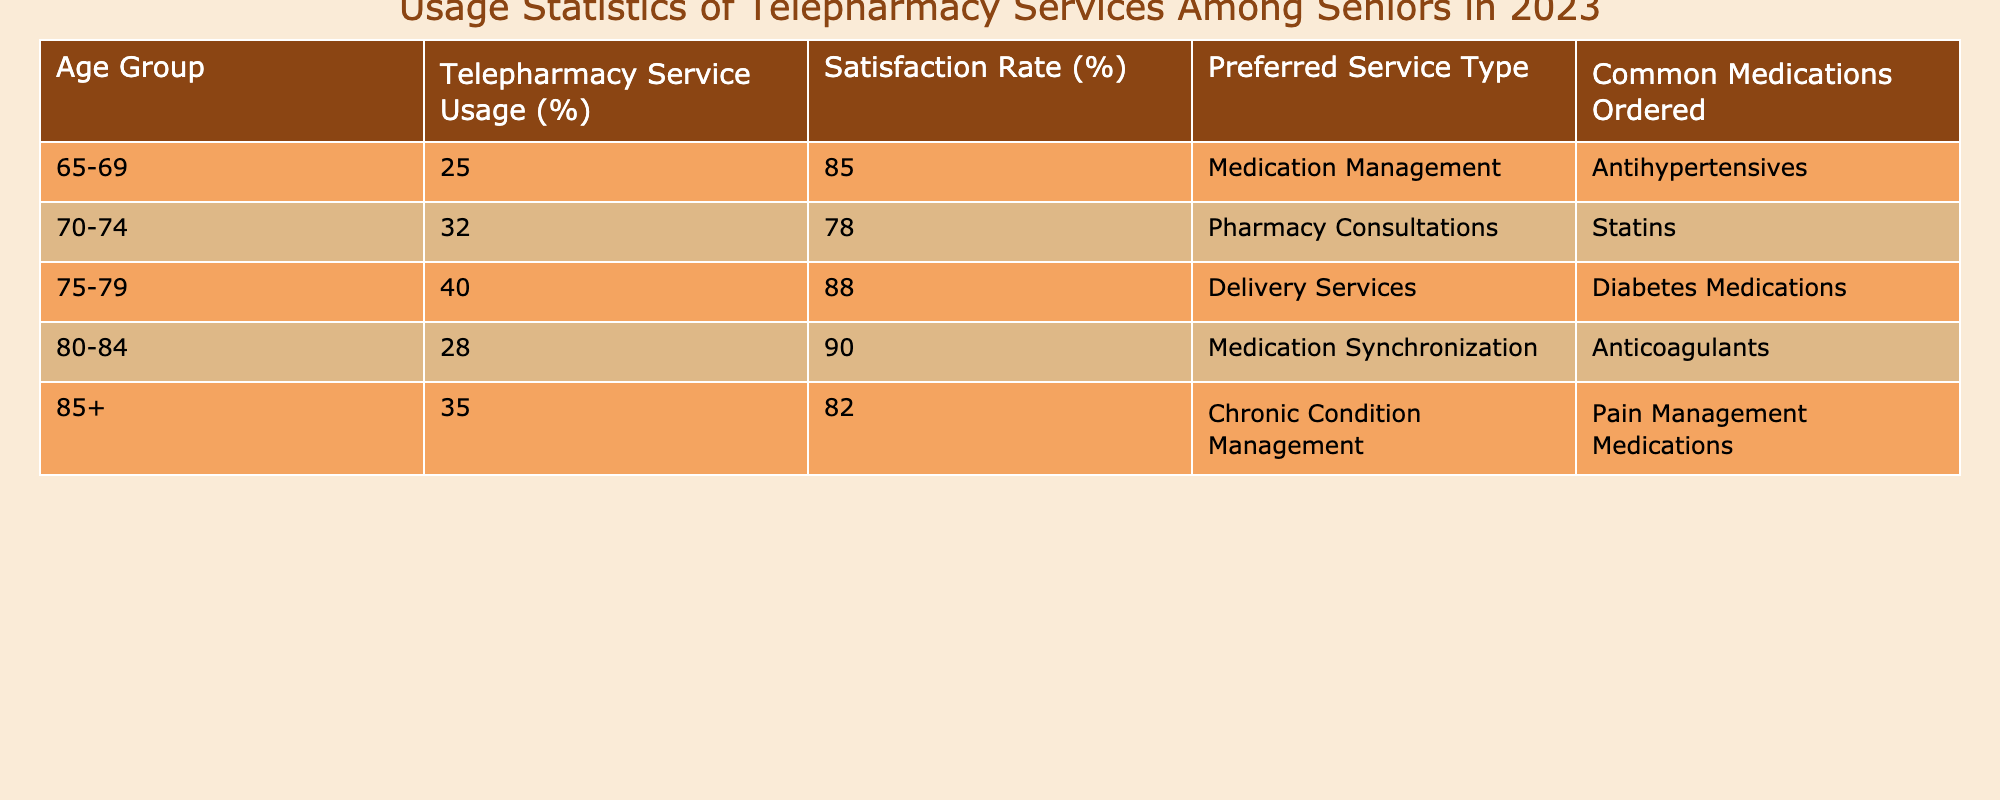What percentage of seniors aged 75-79 use telepharmacy services? According to the table, the percentage of seniors aged 75-79 who use telepharmacy services is explicitly stated as 40%.
Answer: 40% What is the satisfaction rate for seniors aged 80-84? The table shows that the satisfaction rate for seniors aged 80-84 is 90%.
Answer: 90% Which age group has the highest percentage of telepharmacy service usage? By comparing the usage percentages across the age groups, it's clear that seniors aged 75-79 have the highest percentage at 40%.
Answer: 75-79 What is the preferred service type for seniors aged 70-74? The table indicates that the preferred service type for this age group is Pharmacy Consultations.
Answer: Pharmacy Consultations What's the average satisfaction rate across all age groups? To find the average, add the satisfaction rates (85 + 78 + 88 + 90 + 82) = 421, and then divide by 5 (the number of groups), which equals 84.2%.
Answer: 84.2% Do more seniors aged 65-69 prefer medication management or delivery services? The table shows that the preferred service for seniors aged 65-69 is Medication Management, while the preferred service for the 75-79 age group is Delivery Services. Since 65-69 prefers Medication Management, the answer is yes.
Answer: Yes How much higher is the telepharmacy usage percentage for the 75-79 age group compared to the 65-69 age group? The percentage for the 75-79 age group is 40% and for the 65-69 age group it is 25%. The difference is 40% - 25% = 15%.
Answer: 15% Which common medication is ordered most frequently among seniors aged 80-84? The table specifies that seniors aged 80-84 typically order Anticoagulants.
Answer: Anticoagulants Is the satisfaction rate for the 85+ age group lower than that of the 70-74 age group? The satisfaction rate for the 85+ age group is 82%, whereas for the 70-74 age group it is 78%. Since 82% is greater than 78%, the answer is no.
Answer: No What percentage of seniors aged 75-79 are satisfied with telepharmacy services? The satisfaction rate for seniors in the 75-79 age group is provided in the table as 88%.
Answer: 88% If a senior in the 80-84 age group chooses medication synchronization, will they likely be satisfied? Given that the satisfaction rate for the 80-84 age group is 90%, which is high, it indicates they will likely be satisfied.
Answer: Likely yes 